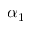Convert formula to latex. <formula><loc_0><loc_0><loc_500><loc_500>\alpha _ { 1 }</formula> 